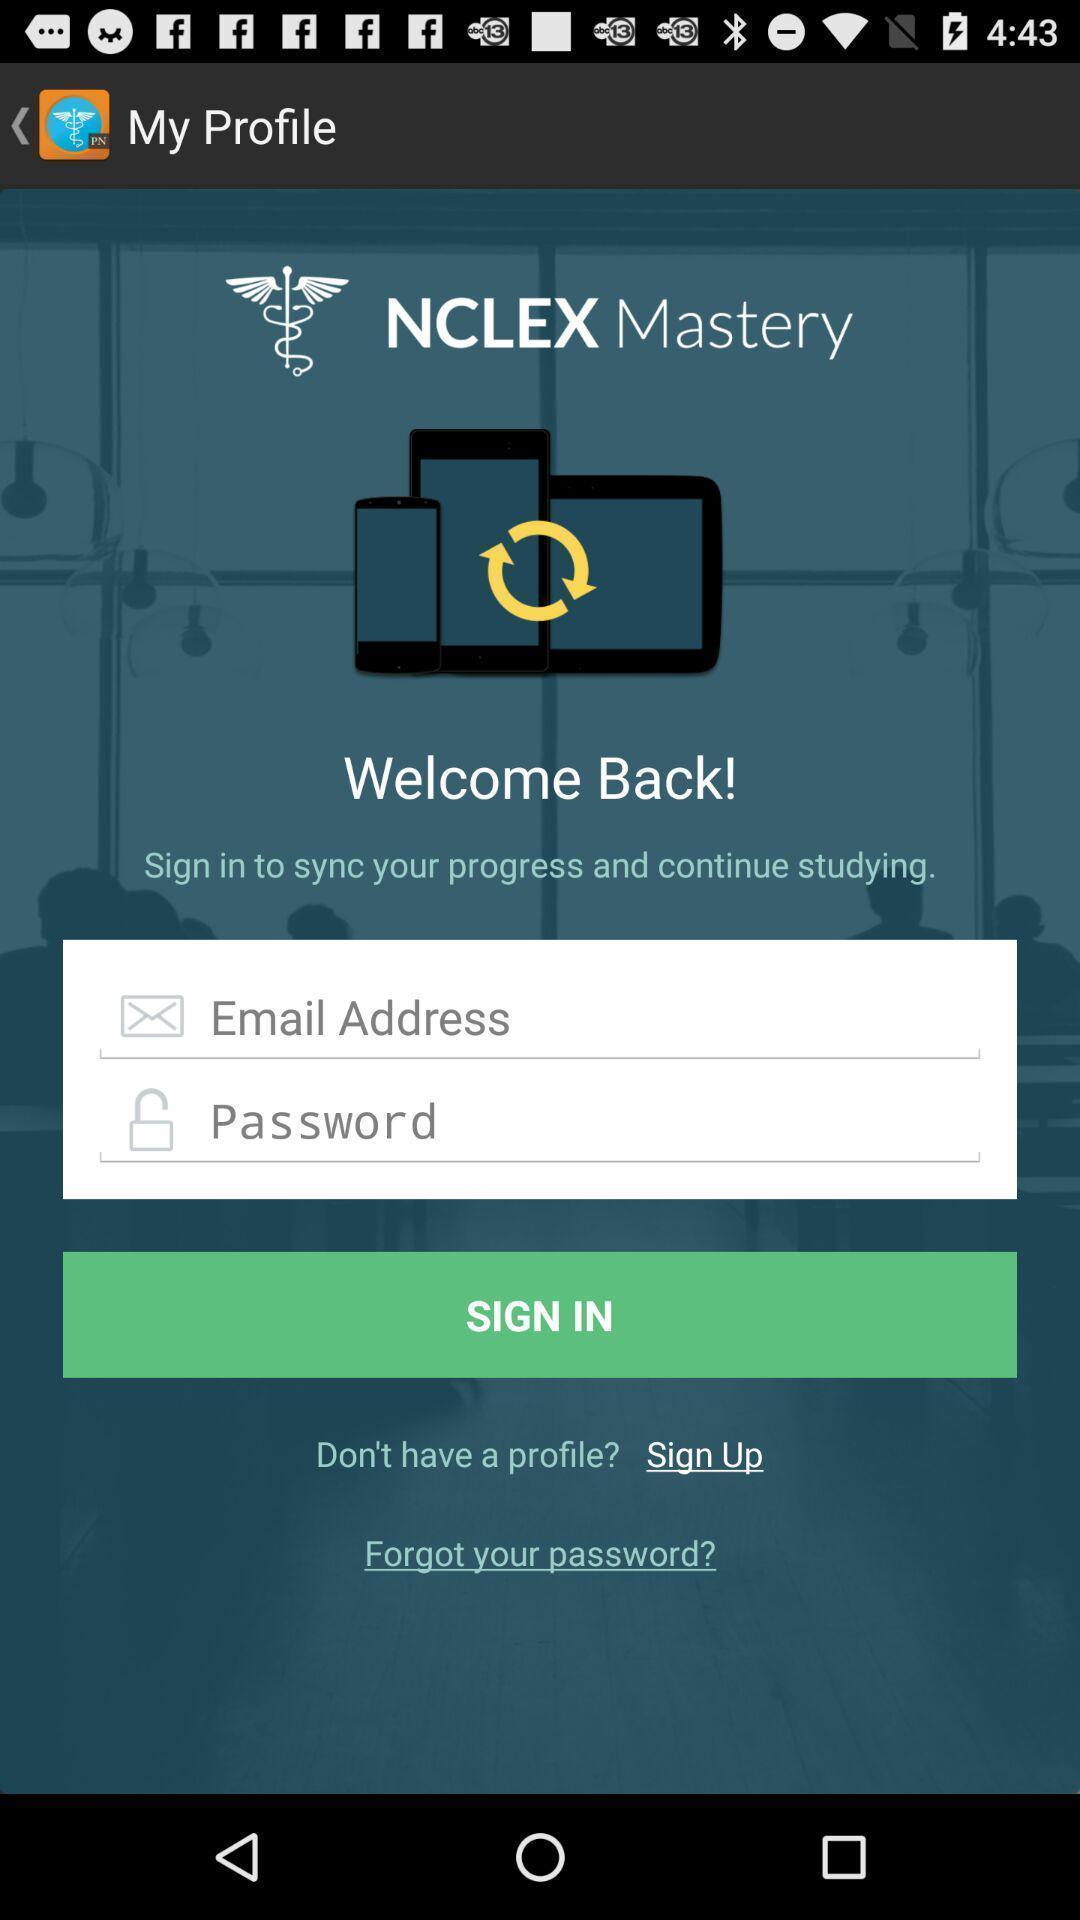Please provide a description for this image. Welcome and log-in page for an application. 